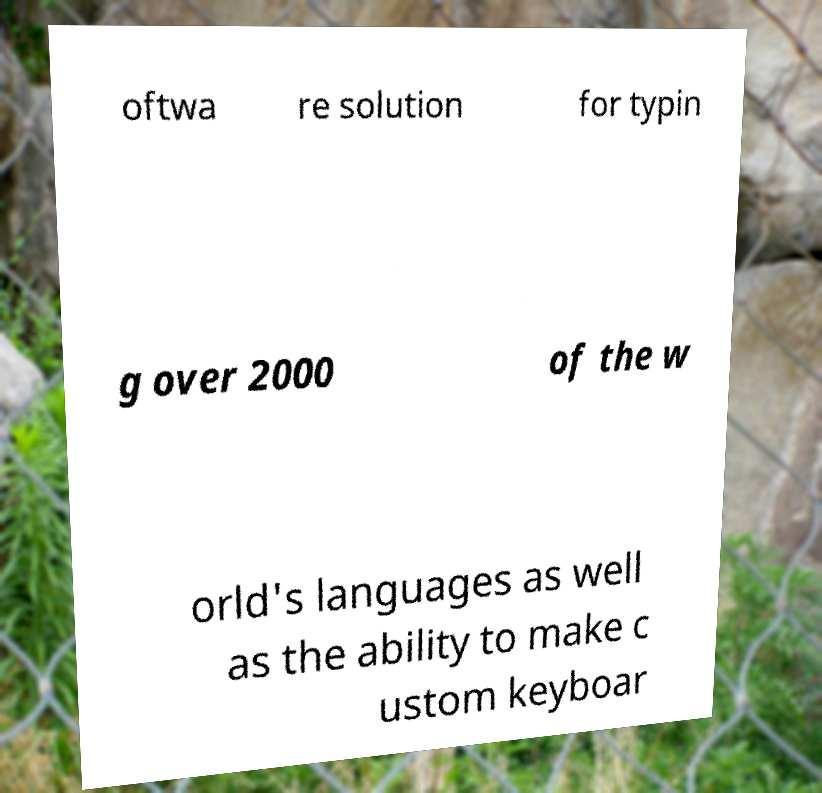Can you accurately transcribe the text from the provided image for me? oftwa re solution for typin g over 2000 of the w orld's languages as well as the ability to make c ustom keyboar 